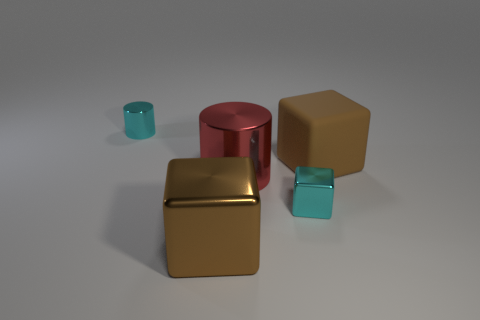What number of other objects are the same material as the cyan block?
Keep it short and to the point. 3. Are there an equal number of big metal cylinders that are to the left of the large metallic block and big brown shiny cubes that are to the right of the big brown matte thing?
Offer a terse response. Yes. There is a object that is on the right side of the small metal object that is in front of the tiny object that is on the left side of the large brown metallic thing; what is its color?
Ensure brevity in your answer.  Brown. What is the shape of the brown object that is in front of the red thing?
Give a very brief answer. Cube. What shape is the big thing that is the same material as the red cylinder?
Offer a very short reply. Cube. Is there any other thing that has the same shape as the big red thing?
Give a very brief answer. Yes. There is a large red cylinder; how many large things are in front of it?
Ensure brevity in your answer.  1. Is the number of cyan blocks in front of the brown metallic thing the same as the number of large shiny spheres?
Your answer should be very brief. Yes. Are the cyan cube and the large red thing made of the same material?
Your answer should be compact. Yes. There is a thing that is both behind the red thing and on the left side of the big red metallic object; how big is it?
Make the answer very short. Small. 